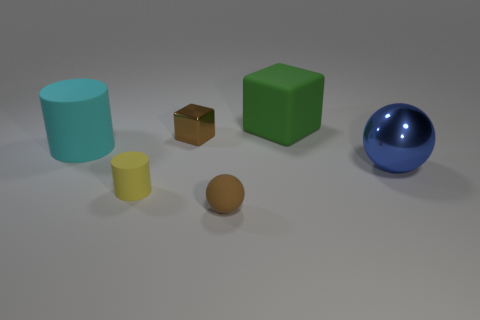There is a small ball that is the same color as the tiny shiny object; what material is it?
Provide a succinct answer. Rubber. There is a sphere that is the same size as the yellow cylinder; what is it made of?
Keep it short and to the point. Rubber. Is there a large ball that has the same color as the metallic cube?
Keep it short and to the point. No. There is a rubber object that is both left of the big green object and behind the yellow object; what shape is it?
Give a very brief answer. Cylinder. How many green things are made of the same material as the large blue thing?
Your answer should be compact. 0. Is the number of small brown cubes that are on the left side of the small yellow matte cylinder less than the number of tiny balls on the right side of the rubber block?
Offer a very short reply. No. There is a block on the right side of the brown object that is behind the matte cylinder that is right of the big matte cylinder; what is its material?
Your answer should be compact. Rubber. How big is the thing that is behind the small yellow rubber cylinder and on the left side of the small cube?
Provide a succinct answer. Large. How many blocks are tiny objects or big green things?
Ensure brevity in your answer.  2. What is the color of the sphere that is the same size as the brown block?
Your answer should be very brief. Brown. 